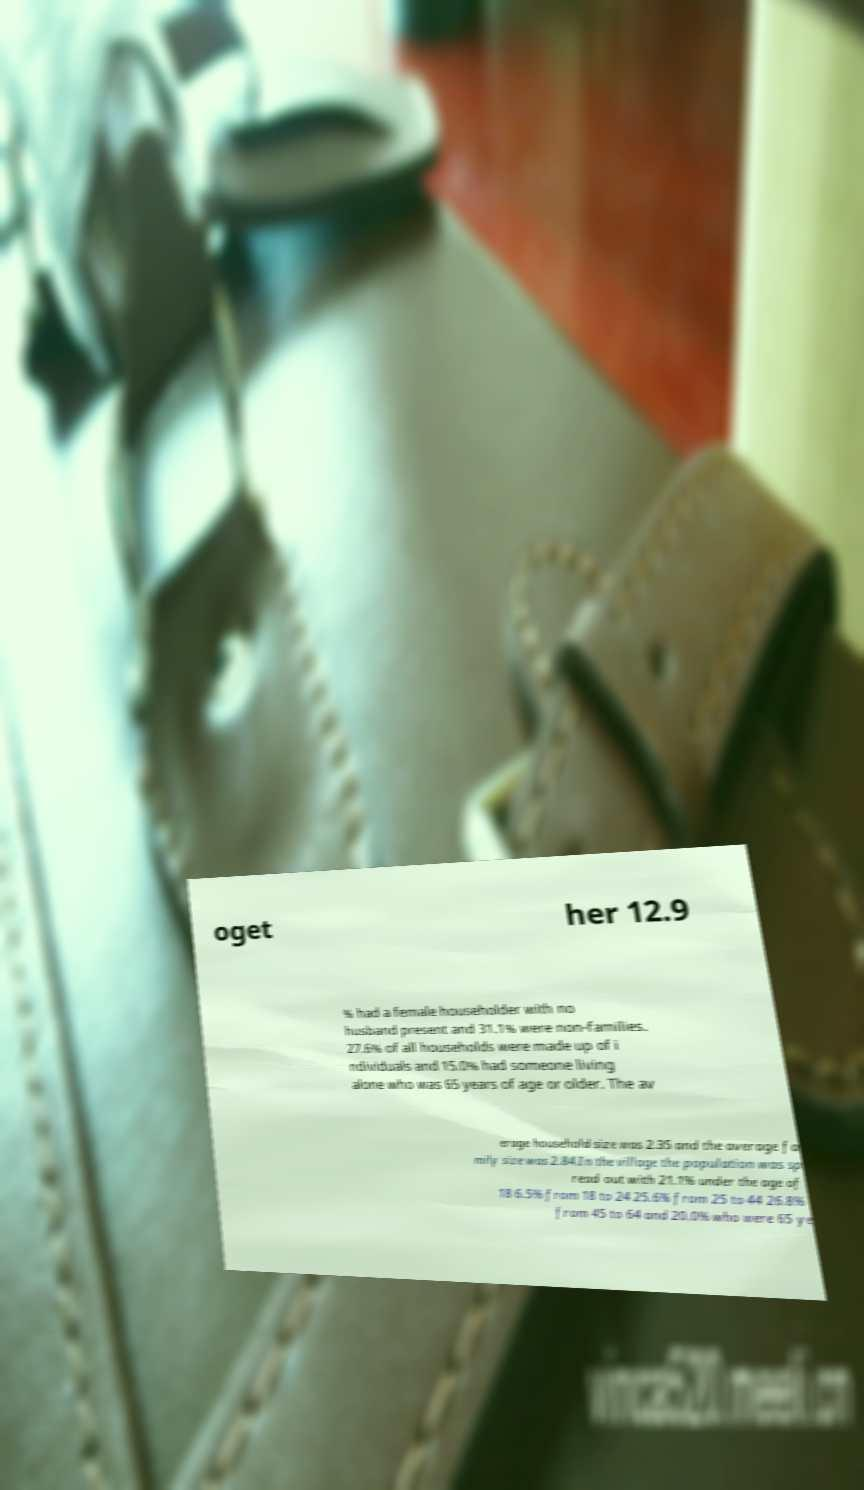What messages or text are displayed in this image? I need them in a readable, typed format. oget her 12.9 % had a female householder with no husband present and 31.1% were non-families. 27.6% of all households were made up of i ndividuals and 15.0% had someone living alone who was 65 years of age or older. The av erage household size was 2.35 and the average fa mily size was 2.84.In the village the population was sp read out with 21.1% under the age of 18 6.5% from 18 to 24 25.6% from 25 to 44 26.8% from 45 to 64 and 20.0% who were 65 ye 